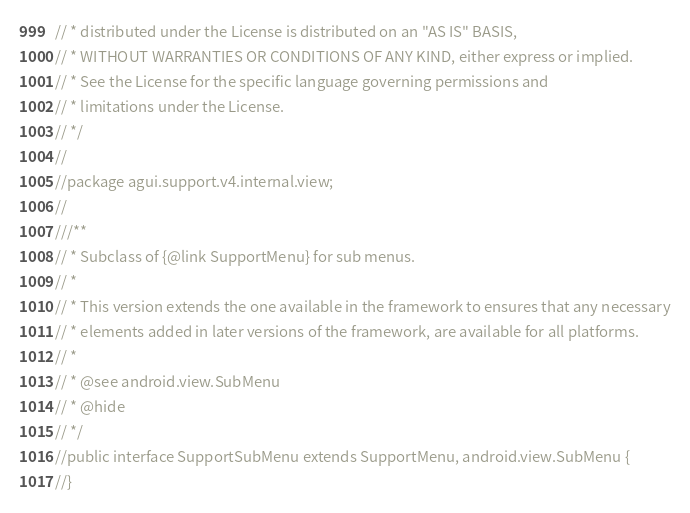Convert code to text. <code><loc_0><loc_0><loc_500><loc_500><_Java_>// * distributed under the License is distributed on an "AS IS" BASIS,
// * WITHOUT WARRANTIES OR CONDITIONS OF ANY KIND, either express or implied.
// * See the License for the specific language governing permissions and
// * limitations under the License.
// */
//
//package agui.support.v4.internal.view;
//
///**
// * Subclass of {@link SupportMenu} for sub menus.
// *
// * This version extends the one available in the framework to ensures that any necessary
// * elements added in later versions of the framework, are available for all platforms.
// *
// * @see android.view.SubMenu
// * @hide
// */
//public interface SupportSubMenu extends SupportMenu, android.view.SubMenu {
//}
</code> 